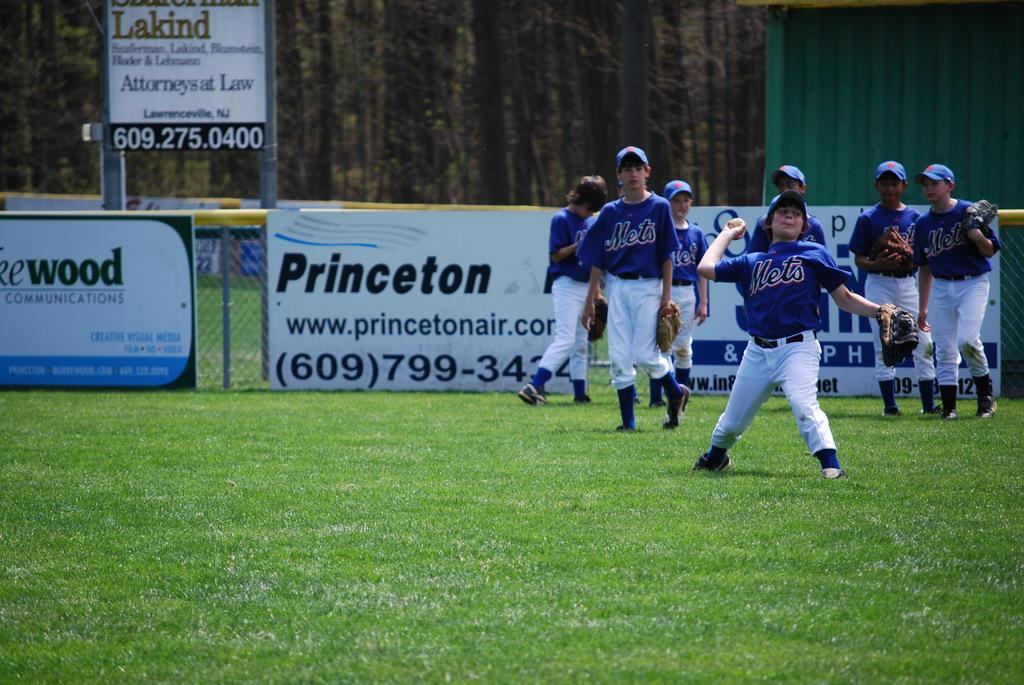<image>
Share a concise interpretation of the image provided. one of the sponsors of the baseball game is Princeton Air 